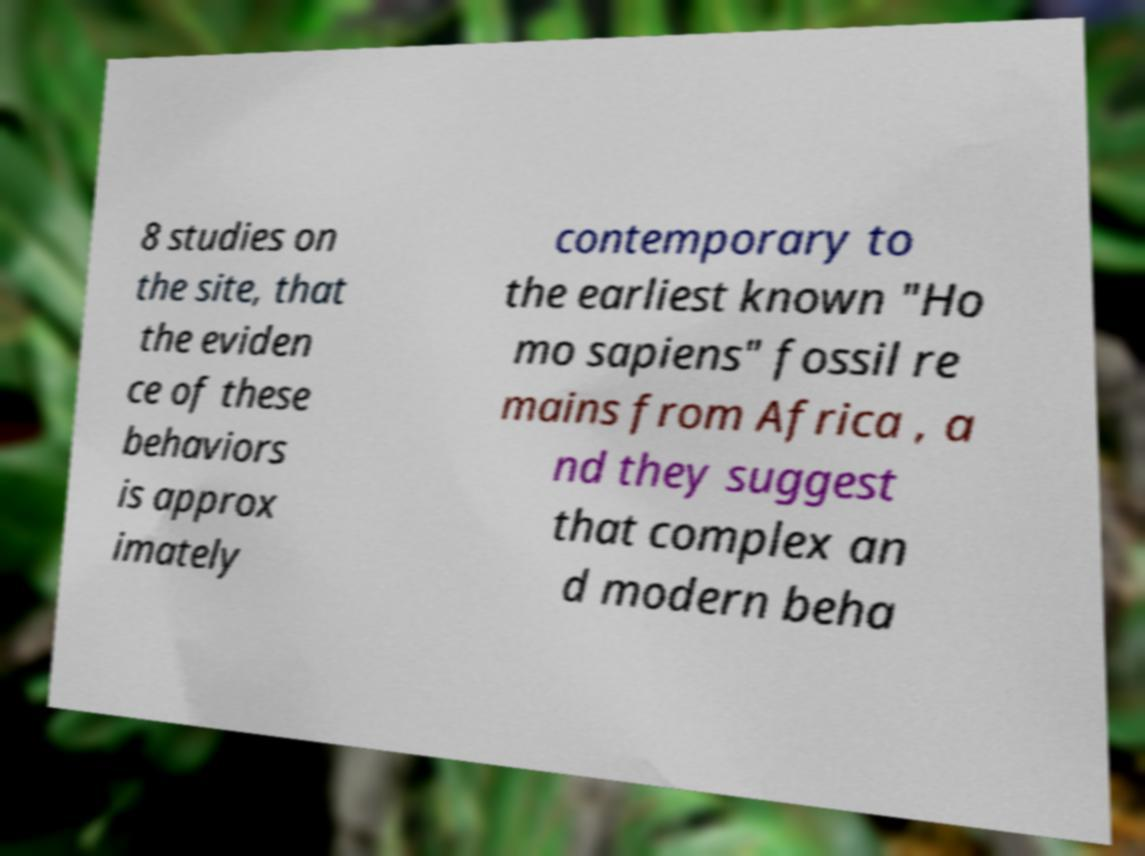Can you accurately transcribe the text from the provided image for me? 8 studies on the site, that the eviden ce of these behaviors is approx imately contemporary to the earliest known "Ho mo sapiens" fossil re mains from Africa , a nd they suggest that complex an d modern beha 